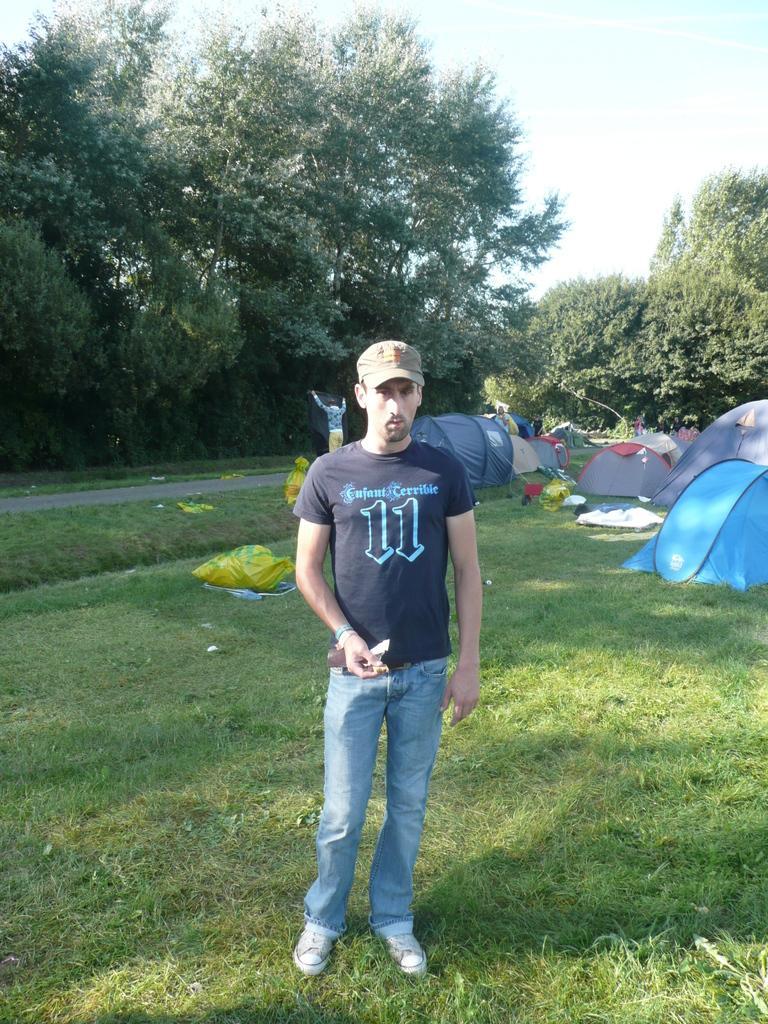Describe this image in one or two sentences. In the center of the image there is a person standing on the grass. In the background of the image there are trees, tents,road. 